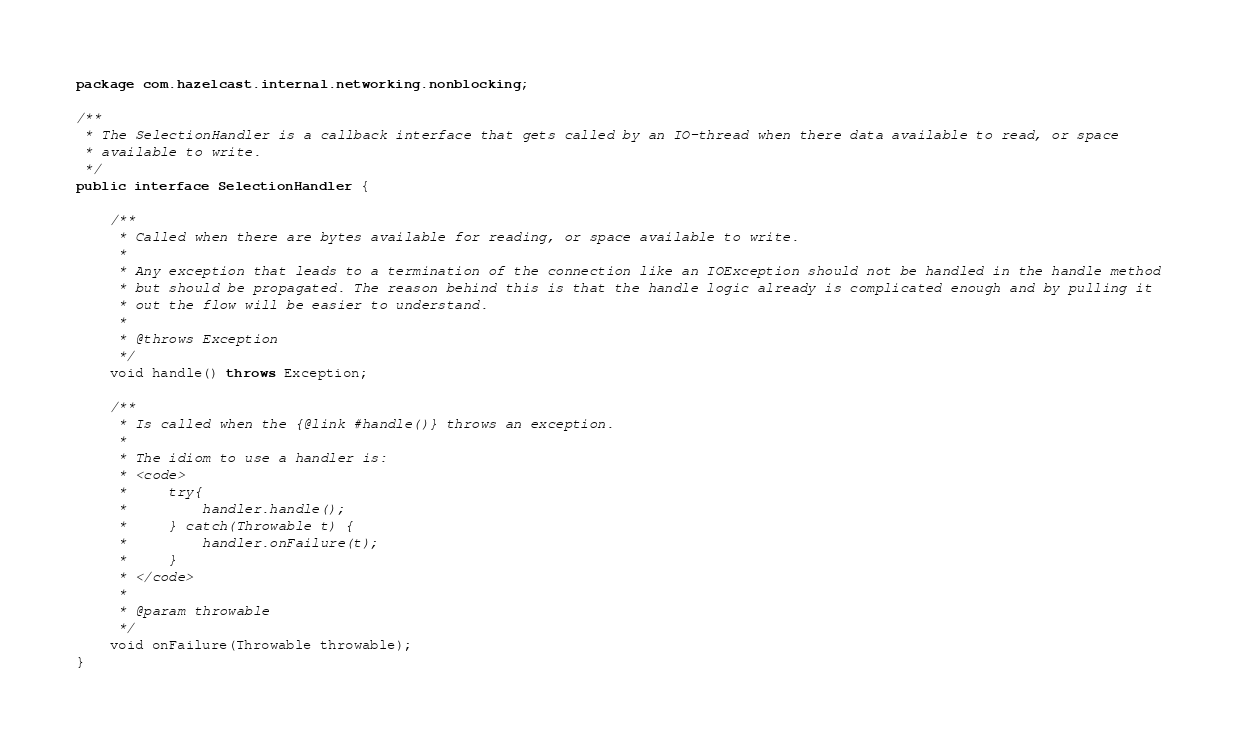Convert code to text. <code><loc_0><loc_0><loc_500><loc_500><_Java_>package com.hazelcast.internal.networking.nonblocking;

/**
 * The SelectionHandler is a callback interface that gets called by an IO-thread when there data available to read, or space
 * available to write.
 */
public interface SelectionHandler {

    /**
     * Called when there are bytes available for reading, or space available to write.
     *
     * Any exception that leads to a termination of the connection like an IOException should not be handled in the handle method
     * but should be propagated. The reason behind this is that the handle logic already is complicated enough and by pulling it
     * out the flow will be easier to understand.
     *
     * @throws Exception
     */
    void handle() throws Exception;

    /**
     * Is called when the {@link #handle()} throws an exception.
     *
     * The idiom to use a handler is:
     * <code>
     *     try{
     *         handler.handle();
     *     } catch(Throwable t) {
     *         handler.onFailure(t);
     *     }
     * </code>
     *
     * @param throwable
     */
    void onFailure(Throwable throwable);
}
</code> 